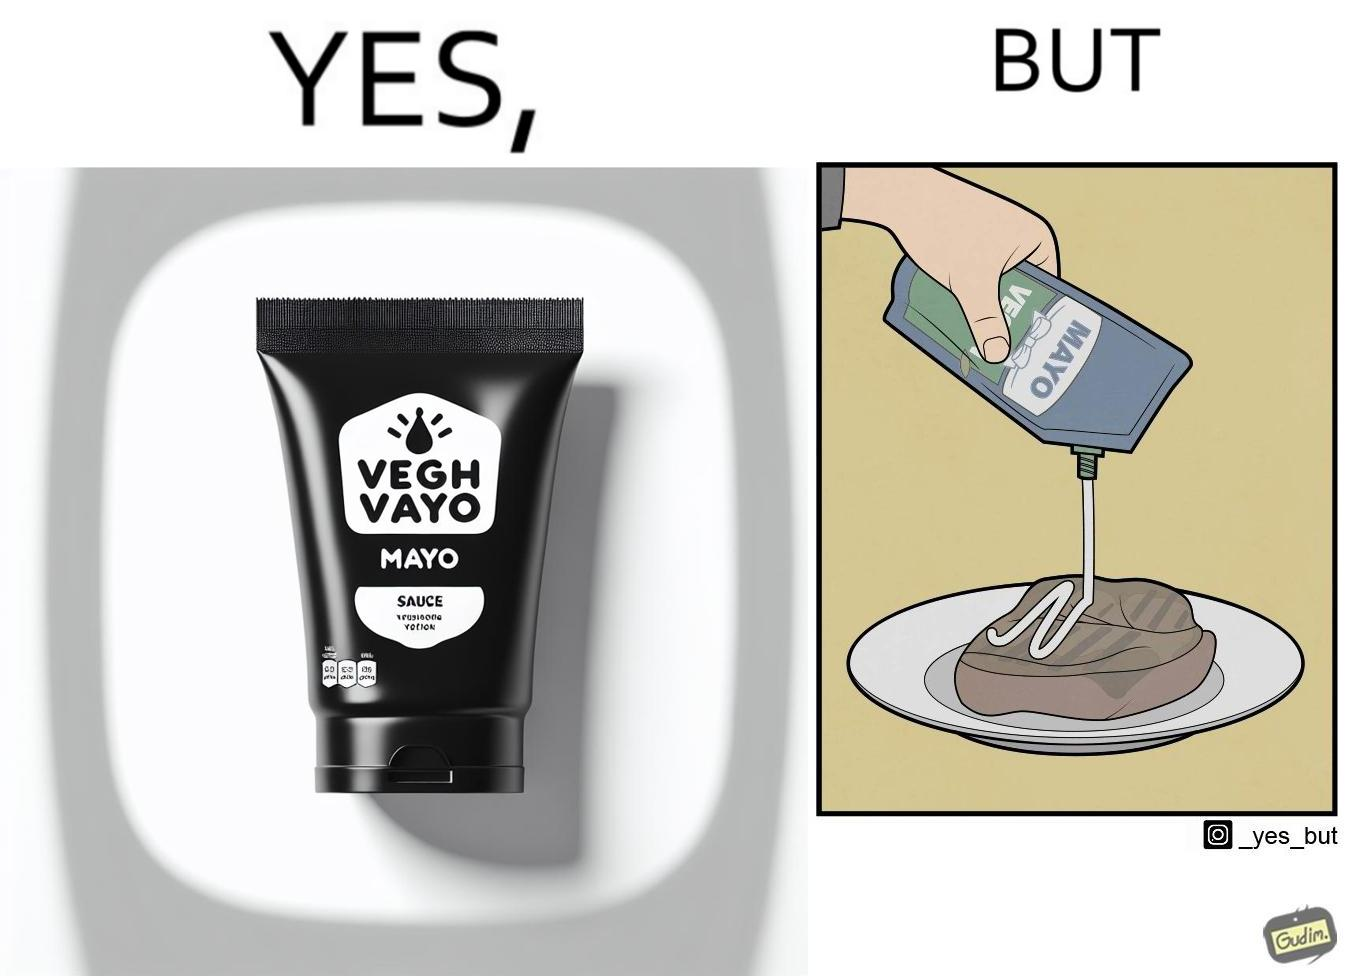Is there satirical content in this image? Yes, this image is satirical. 